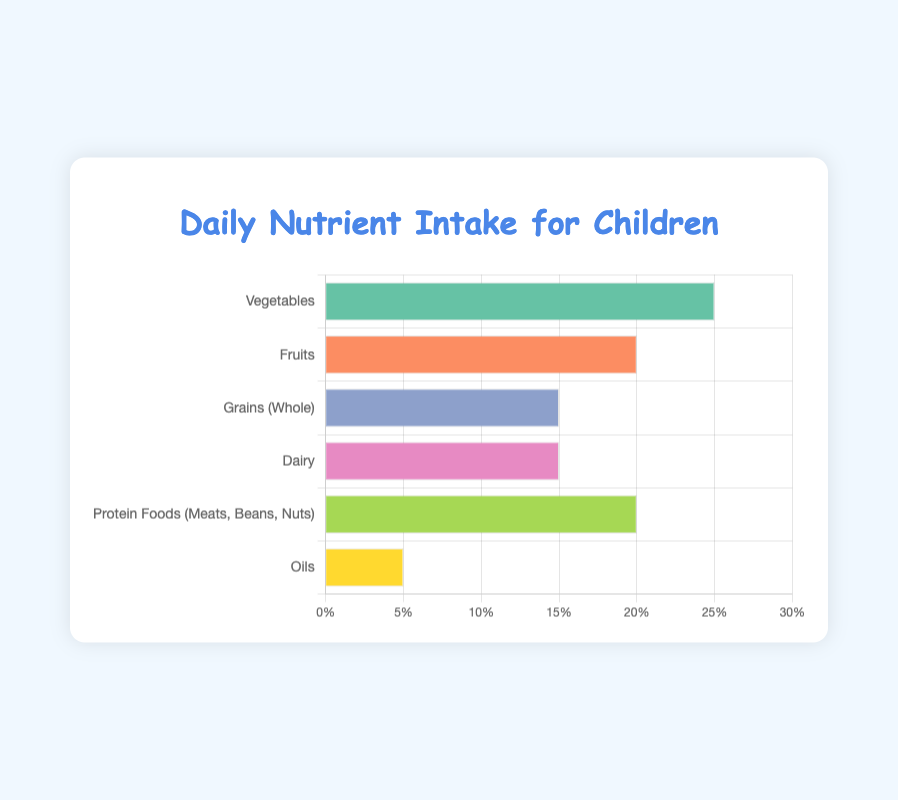Which food group contributes the highest percentage of daily nutrient intake for children? The bar for "Vegetables" is the longest in the figure, representing the highest percentage of daily nutrient intake.
Answer: Vegetables Which two food groups together make up 40% of the daily nutrient intake? "Fruits" and "Protein Foods (Meats, Beans, Nuts)" each contribute 20%, and their combined total is 20% + 20% = 40%.
Answer: Fruits and Protein Foods (Meats, Beans, Nuts) How does the percentage of daily nutrient intake from Dairy compare to that from Grains (Whole)? Both "Dairy" and "Grains (Whole)" have bars of the same length, each representing 15% of the daily nutrient intake.
Answer: They are equal Which color represents the "Oils" food group in the chart? The bar representing "Oils" is colored yellow.
Answer: Yellow If we combine the daily nutrient intake percentages from Vegetables and Oils, how much more is it than the intake from Dairy alone? The percentage from Vegetables is 25%, from Oils is 5%, and Dairy alone is 15%. So the combined total from Vegetables and Oils is 25% + 5% = 30%, which is 30% - 15% = 15% more than Dairy.
Answer: 15% more What is the combined percentage of daily nutrient intake from Vegetables, Fruits, and Grains (Whole)? Vegetables contribute 25%, Fruits 20%, and Grains (Whole) 15%. The combined total is 25% + 20% + 15% = 60%.
Answer: 60% Which food groups contribute exactly 20% of the daily nutrient intake each? The bars labeled "Fruits" and "Protein Foods (Meats, Beans, Nuts)" both reach the 20% mark.
Answer: Fruits and Protein Foods (Meats, Beans, Nuts) How much higher is the percentage of daily nutrient intake from Vegetables compared to Oils? The percentage from Vegetables is 25%, and from Oils, it is 5%. The difference is 25% - 5% = 20%.
Answer: 20% higher Is the percentage of daily nutrient intake from Protein Foods combined with Oils more or less than that from Fruits? Protein Foods contribute 20% and Oils 5%, making a combined total of 20% + 5% = 25%, which is more than the 20% from Fruits.
Answer: More 